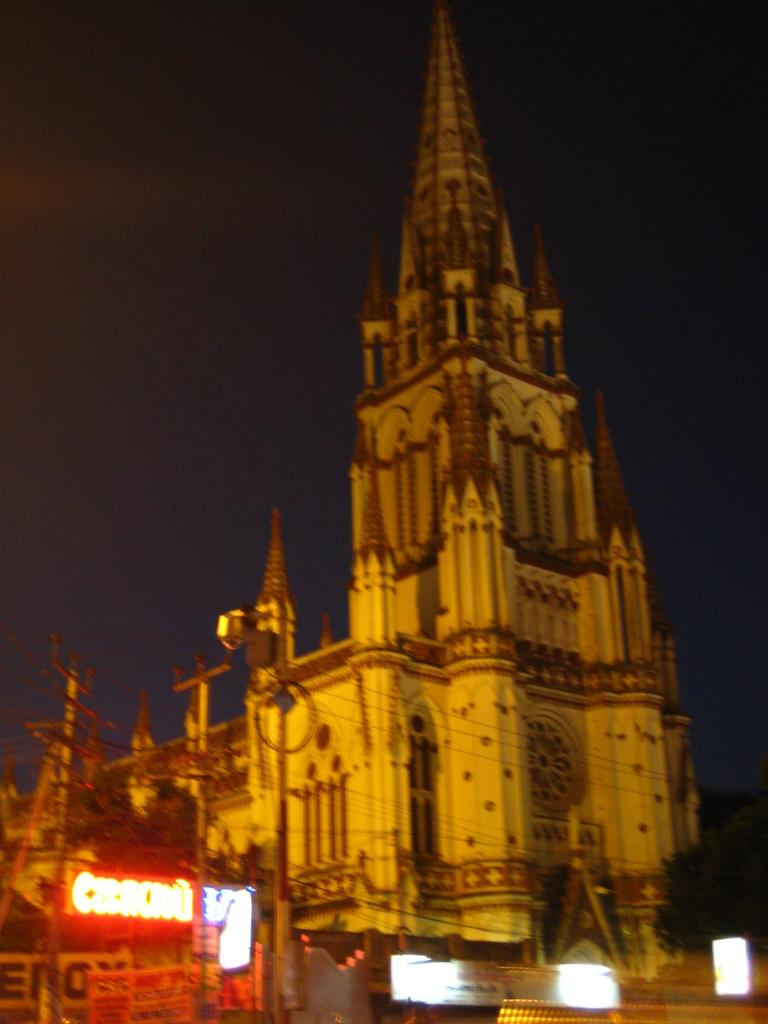What type of structure is present in the image? There is a building in the image. What else can be seen in the image besides the building? There are poles and a sign board in the image. Is there any vegetation visible in the image? Yes, there is a tree to the right side of the image. What can be seen in the background of the image? The sky is visible in the background of the image. What type of powder is being used to make the bread in the image? There is no bread or powder present in the image. 